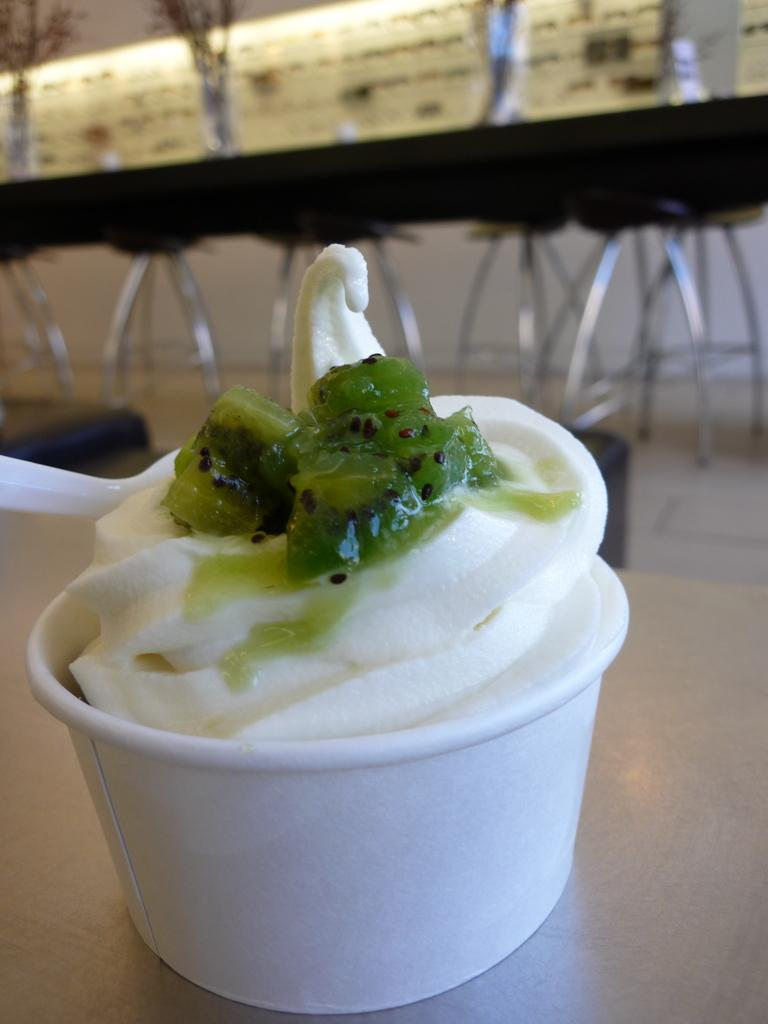What type of food item is on the table in the image? There is a cupcake on the table in the image. What can be seen in the background of the image? Tables and chairs are visible in the background of the image. What type of lighting is present in the image? Lights and tube lights are present at the top of the image. Can you see any waves crashing on the shore in the image? There are no waves or shore visible in the image; it features a cupcake on a table. How many wheels are present in the image? There are no wheels present in the image. 